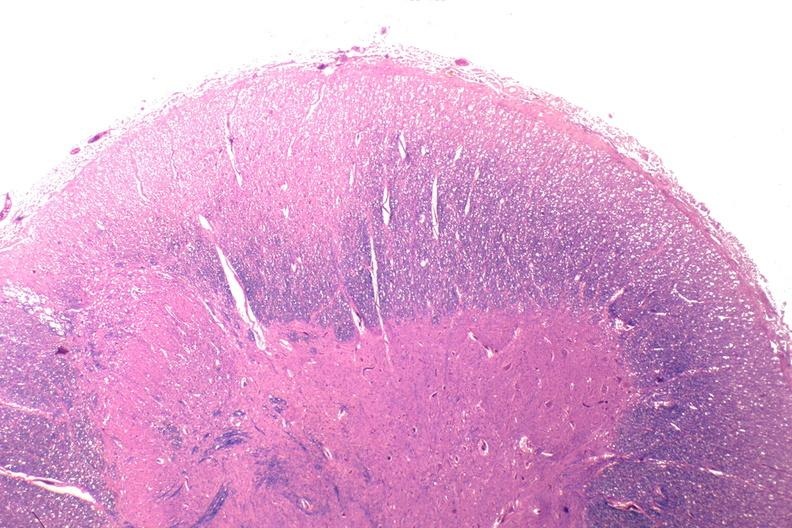does this image show spinal cord injury due to vertebral column trauma, demyelination?
Answer the question using a single word or phrase. Yes 